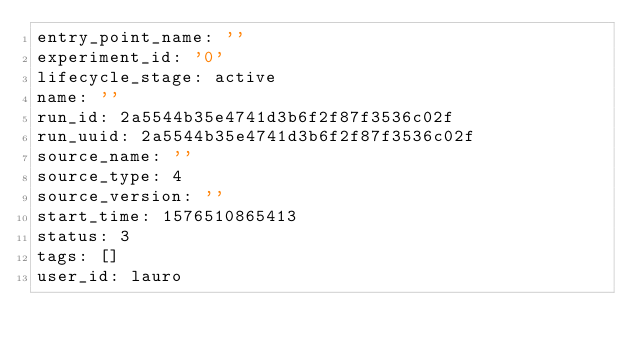<code> <loc_0><loc_0><loc_500><loc_500><_YAML_>entry_point_name: ''
experiment_id: '0'
lifecycle_stage: active
name: ''
run_id: 2a5544b35e4741d3b6f2f87f3536c02f
run_uuid: 2a5544b35e4741d3b6f2f87f3536c02f
source_name: ''
source_type: 4
source_version: ''
start_time: 1576510865413
status: 3
tags: []
user_id: lauro
</code> 